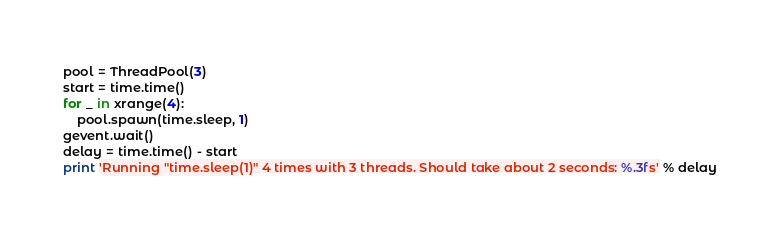<code> <loc_0><loc_0><loc_500><loc_500><_Python_>pool = ThreadPool(3)
start = time.time()
for _ in xrange(4):
    pool.spawn(time.sleep, 1)
gevent.wait()
delay = time.time() - start
print 'Running "time.sleep(1)" 4 times with 3 threads. Should take about 2 seconds: %.3fs' % delay
</code> 